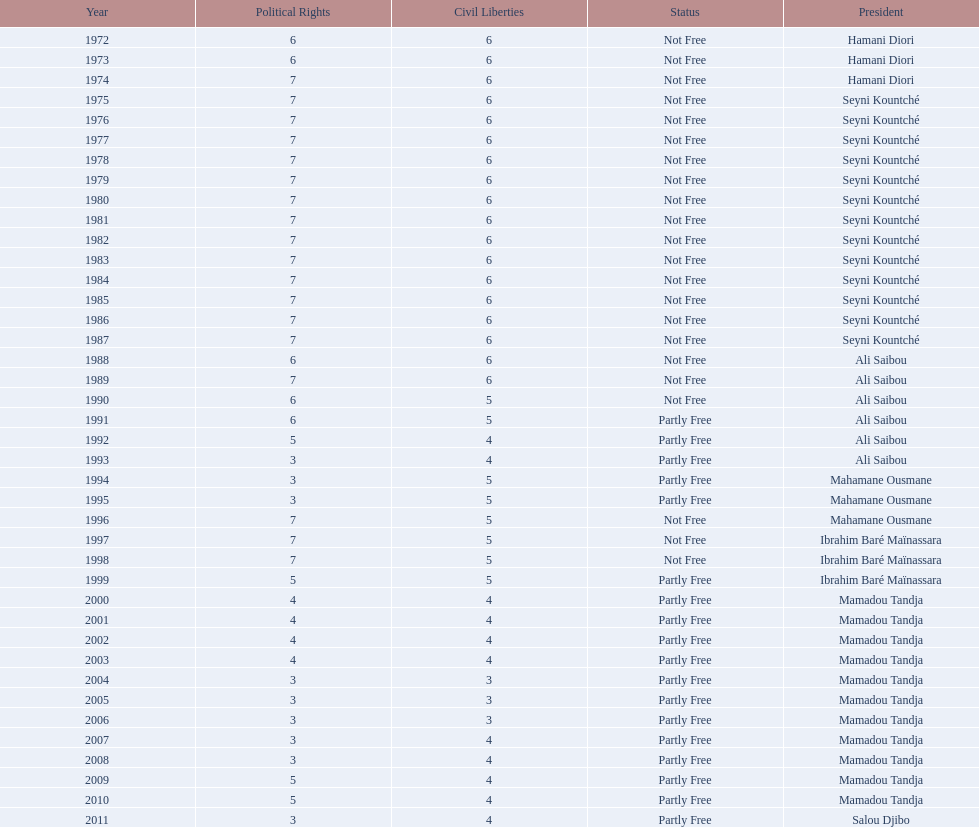What is the number of time seyni kountche has been president? 13. 